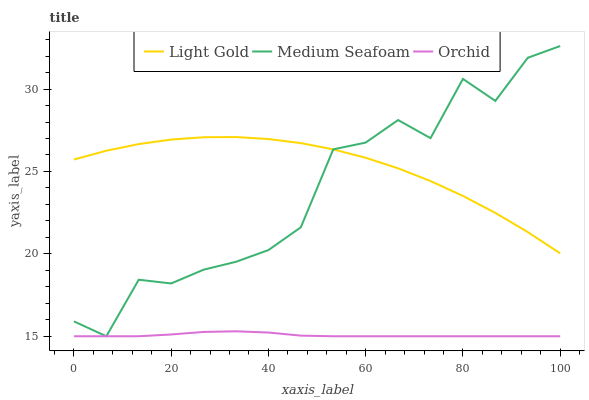Does Medium Seafoam have the minimum area under the curve?
Answer yes or no. No. Does Medium Seafoam have the maximum area under the curve?
Answer yes or no. No. Is Medium Seafoam the smoothest?
Answer yes or no. No. Is Orchid the roughest?
Answer yes or no. No. Does Orchid have the highest value?
Answer yes or no. No. Is Orchid less than Light Gold?
Answer yes or no. Yes. Is Light Gold greater than Orchid?
Answer yes or no. Yes. Does Orchid intersect Light Gold?
Answer yes or no. No. 